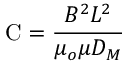Convert formula to latex. <formula><loc_0><loc_0><loc_500><loc_500>C = { \frac { B ^ { 2 } L ^ { 2 } } { \mu _ { o } \mu D _ { M } } }</formula> 